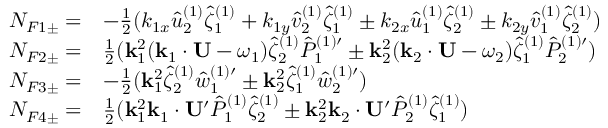<formula> <loc_0><loc_0><loc_500><loc_500>\begin{array} { r l } { N _ { F 1 \pm } = } & { - { \frac { 1 } { 2 } } ( k _ { 1 x } \hat { u } _ { 2 } ^ { ( 1 ) } \hat { \zeta } _ { 1 } ^ { ( 1 ) } + k _ { 1 y } \hat { v } _ { 2 } ^ { ( 1 ) } \hat { \zeta } _ { 1 } ^ { ( 1 ) } \pm k _ { 2 x } \hat { u } _ { 1 } ^ { ( 1 ) } \hat { \zeta } _ { 2 } ^ { ( 1 ) } \pm k _ { 2 y } \hat { v } _ { 1 } ^ { ( 1 ) } \hat { \zeta } _ { 2 } ^ { ( 1 ) } ) } \\ { N _ { F 2 \pm } = } & { { \frac { 1 } { 2 } } ( k _ { 1 } ^ { 2 } ( k _ { 1 } \cdot U - \omega _ { 1 } ) \hat { \zeta } _ { 2 } ^ { ( 1 ) } { \hat { P } _ { 1 } ^ { ( 1 ) \prime } } \pm k _ { 2 } ^ { 2 } ( k _ { 2 } \cdot U - \omega _ { 2 } ) \hat { \zeta } _ { 1 } ^ { ( 1 ) } { \hat { P } _ { 2 } ^ { ( 1 ) \prime } } ) } \\ { N _ { F 3 \pm } = } & { - { \frac { 1 } { 2 } } ( k _ { 1 } ^ { 2 } \hat { \zeta } _ { 2 } ^ { ( 1 ) } { \hat { w } _ { 1 } ^ { ( 1 ) \prime } } \pm k _ { 2 } ^ { 2 } \hat { \zeta } _ { 1 } ^ { ( 1 ) } { \hat { w } _ { 2 } ^ { ( 1 ) \prime } } ) } \\ { N _ { F 4 \pm } = } & { { \frac { 1 } { 2 } } ( k _ { 1 } ^ { 2 } k _ { 1 } \cdot U ^ { \prime } \hat { P } _ { 1 } ^ { ( 1 ) } \hat { \zeta } _ { 2 } ^ { ( 1 ) } \pm k _ { 2 } ^ { 2 } k _ { 2 } \cdot U ^ { \prime } \hat { P } _ { 2 } ^ { ( 1 ) } \hat { \zeta } _ { 1 } ^ { ( 1 ) } ) } \end{array}</formula> 